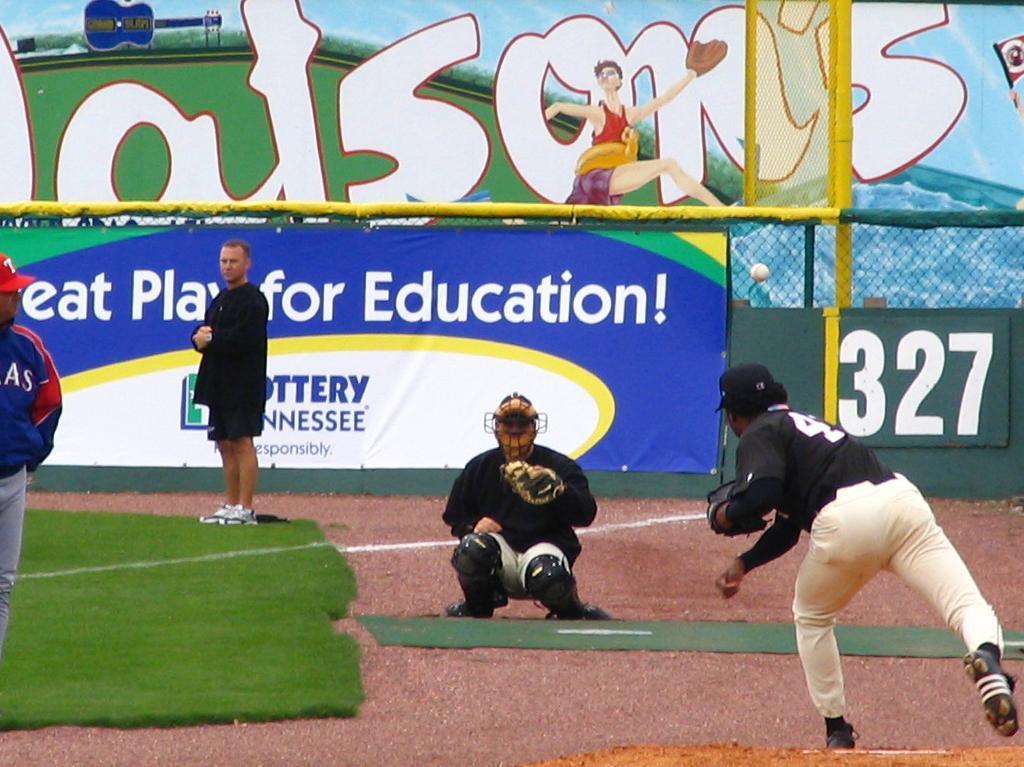Who is pitching the ball?
Offer a very short reply. Unanswerable. How many feet is that outfield fence?
Provide a succinct answer. 327. 